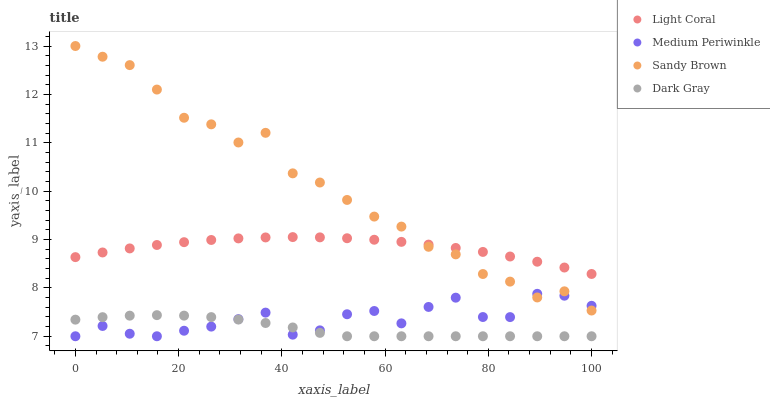Does Dark Gray have the minimum area under the curve?
Answer yes or no. Yes. Does Sandy Brown have the maximum area under the curve?
Answer yes or no. Yes. Does Medium Periwinkle have the minimum area under the curve?
Answer yes or no. No. Does Medium Periwinkle have the maximum area under the curve?
Answer yes or no. No. Is Light Coral the smoothest?
Answer yes or no. Yes. Is Sandy Brown the roughest?
Answer yes or no. Yes. Is Medium Periwinkle the smoothest?
Answer yes or no. No. Is Medium Periwinkle the roughest?
Answer yes or no. No. Does Medium Periwinkle have the lowest value?
Answer yes or no. Yes. Does Sandy Brown have the lowest value?
Answer yes or no. No. Does Sandy Brown have the highest value?
Answer yes or no. Yes. Does Medium Periwinkle have the highest value?
Answer yes or no. No. Is Dark Gray less than Sandy Brown?
Answer yes or no. Yes. Is Light Coral greater than Medium Periwinkle?
Answer yes or no. Yes. Does Dark Gray intersect Medium Periwinkle?
Answer yes or no. Yes. Is Dark Gray less than Medium Periwinkle?
Answer yes or no. No. Is Dark Gray greater than Medium Periwinkle?
Answer yes or no. No. Does Dark Gray intersect Sandy Brown?
Answer yes or no. No. 